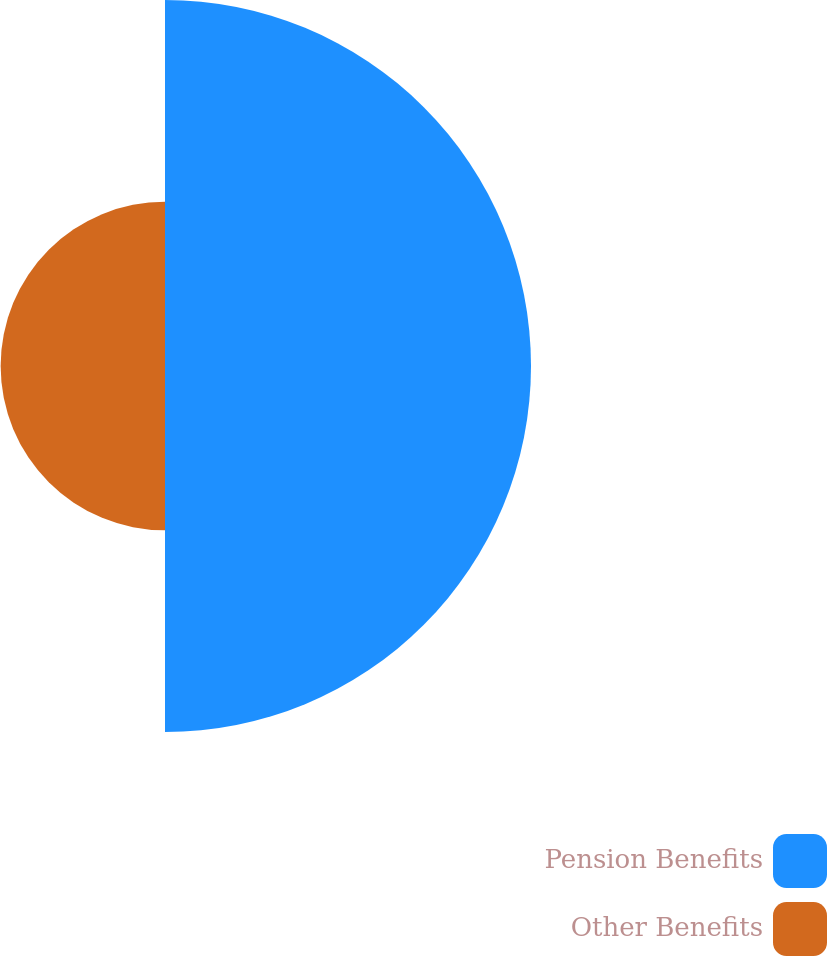<chart> <loc_0><loc_0><loc_500><loc_500><pie_chart><fcel>Pension Benefits<fcel>Other Benefits<nl><fcel>69.01%<fcel>30.99%<nl></chart> 